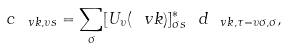<formula> <loc_0><loc_0><loc_500><loc_500>c _ { \ v k , \upsilon s } = \sum _ { \sigma } [ U _ { \upsilon } ( \ v k ) ] _ { \sigma s } ^ { * } \ d _ { \ v k , \tau = \upsilon \sigma , \sigma } ,</formula> 